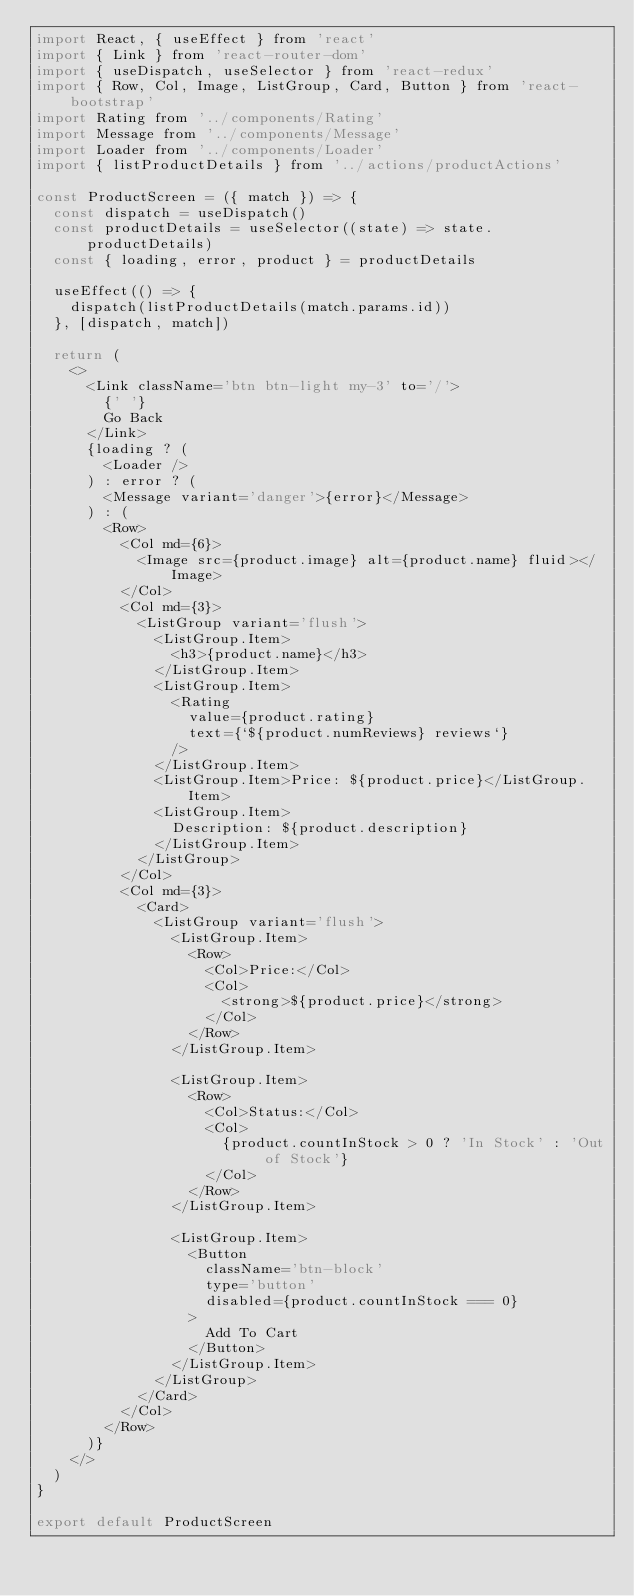<code> <loc_0><loc_0><loc_500><loc_500><_JavaScript_>import React, { useEffect } from 'react'
import { Link } from 'react-router-dom'
import { useDispatch, useSelector } from 'react-redux'
import { Row, Col, Image, ListGroup, Card, Button } from 'react-bootstrap'
import Rating from '../components/Rating'
import Message from '../components/Message'
import Loader from '../components/Loader'
import { listProductDetails } from '../actions/productActions'

const ProductScreen = ({ match }) => {
  const dispatch = useDispatch()
  const productDetails = useSelector((state) => state.productDetails)
  const { loading, error, product } = productDetails

  useEffect(() => {
    dispatch(listProductDetails(match.params.id))
  }, [dispatch, match])

  return (
    <>
      <Link className='btn btn-light my-3' to='/'>
        {' '}
        Go Back
      </Link>
      {loading ? (
        <Loader />
      ) : error ? (
        <Message variant='danger'>{error}</Message>
      ) : (
        <Row>
          <Col md={6}>
            <Image src={product.image} alt={product.name} fluid></Image>
          </Col>
          <Col md={3}>
            <ListGroup variant='flush'>
              <ListGroup.Item>
                <h3>{product.name}</h3>
              </ListGroup.Item>
              <ListGroup.Item>
                <Rating
                  value={product.rating}
                  text={`${product.numReviews} reviews`}
                />
              </ListGroup.Item>
              <ListGroup.Item>Price: ${product.price}</ListGroup.Item>
              <ListGroup.Item>
                Description: ${product.description}
              </ListGroup.Item>
            </ListGroup>
          </Col>
          <Col md={3}>
            <Card>
              <ListGroup variant='flush'>
                <ListGroup.Item>
                  <Row>
                    <Col>Price:</Col>
                    <Col>
                      <strong>${product.price}</strong>
                    </Col>
                  </Row>
                </ListGroup.Item>

                <ListGroup.Item>
                  <Row>
                    <Col>Status:</Col>
                    <Col>
                      {product.countInStock > 0 ? 'In Stock' : 'Out of Stock'}
                    </Col>
                  </Row>
                </ListGroup.Item>

                <ListGroup.Item>
                  <Button
                    className='btn-block'
                    type='button'
                    disabled={product.countInStock === 0}
                  >
                    Add To Cart
                  </Button>
                </ListGroup.Item>
              </ListGroup>
            </Card>
          </Col>
        </Row>
      )}
    </>
  )
}

export default ProductScreen
</code> 